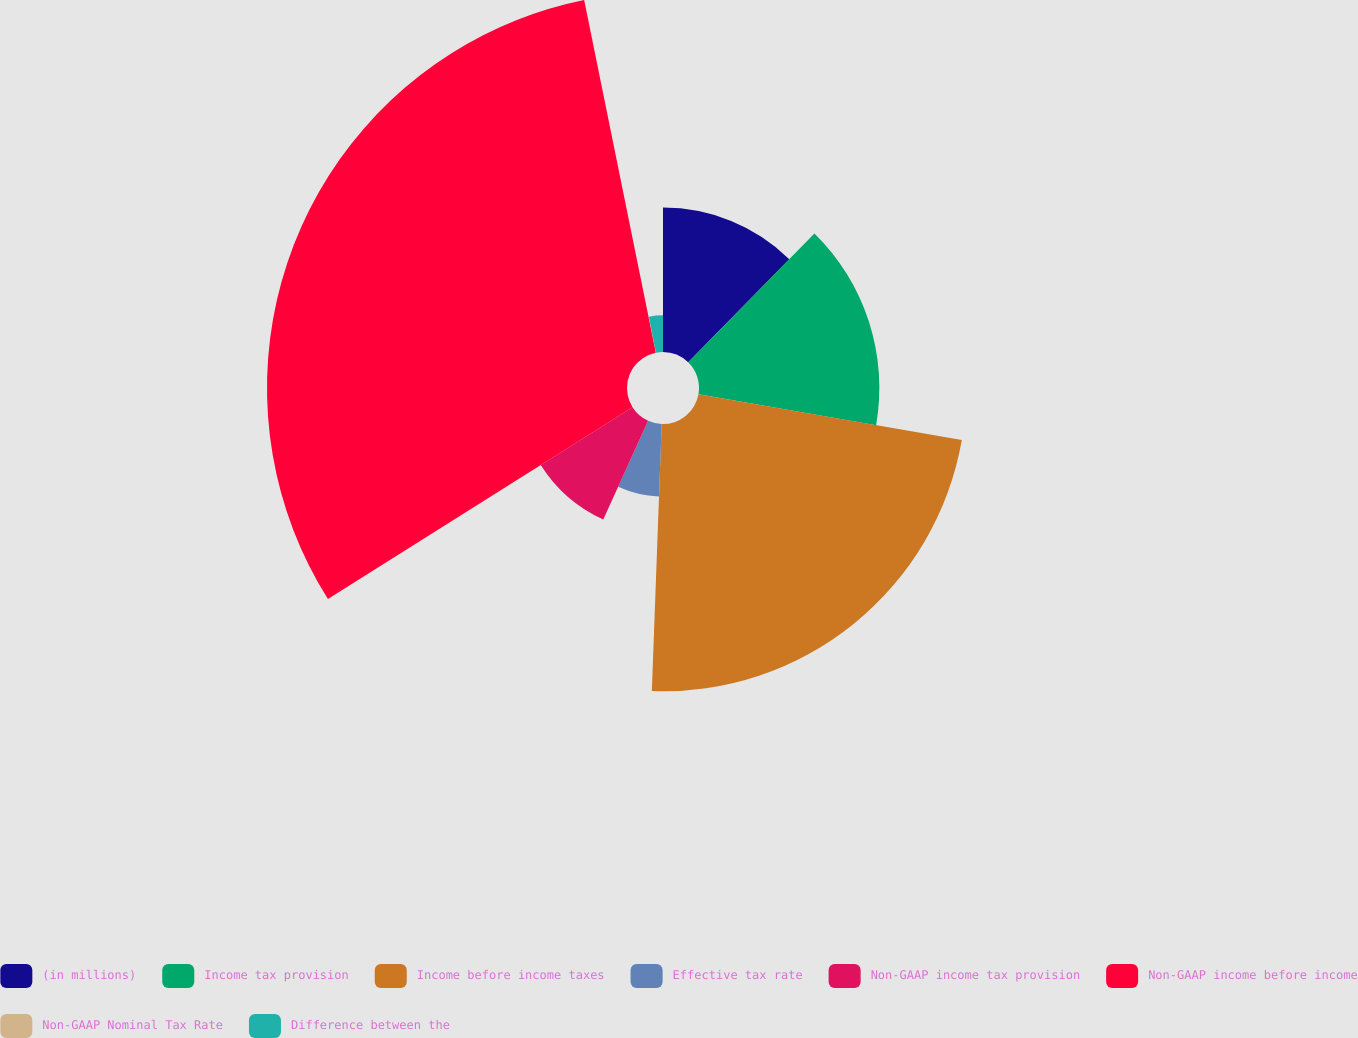Convert chart. <chart><loc_0><loc_0><loc_500><loc_500><pie_chart><fcel>(in millions)<fcel>Income tax provision<fcel>Income before income taxes<fcel>Effective tax rate<fcel>Non-GAAP income tax provision<fcel>Non-GAAP income before income<fcel>Non-GAAP Nominal Tax Rate<fcel>Difference between the<nl><fcel>12.34%<fcel>15.41%<fcel>22.84%<fcel>6.2%<fcel>9.27%<fcel>30.76%<fcel>0.06%<fcel>3.13%<nl></chart> 